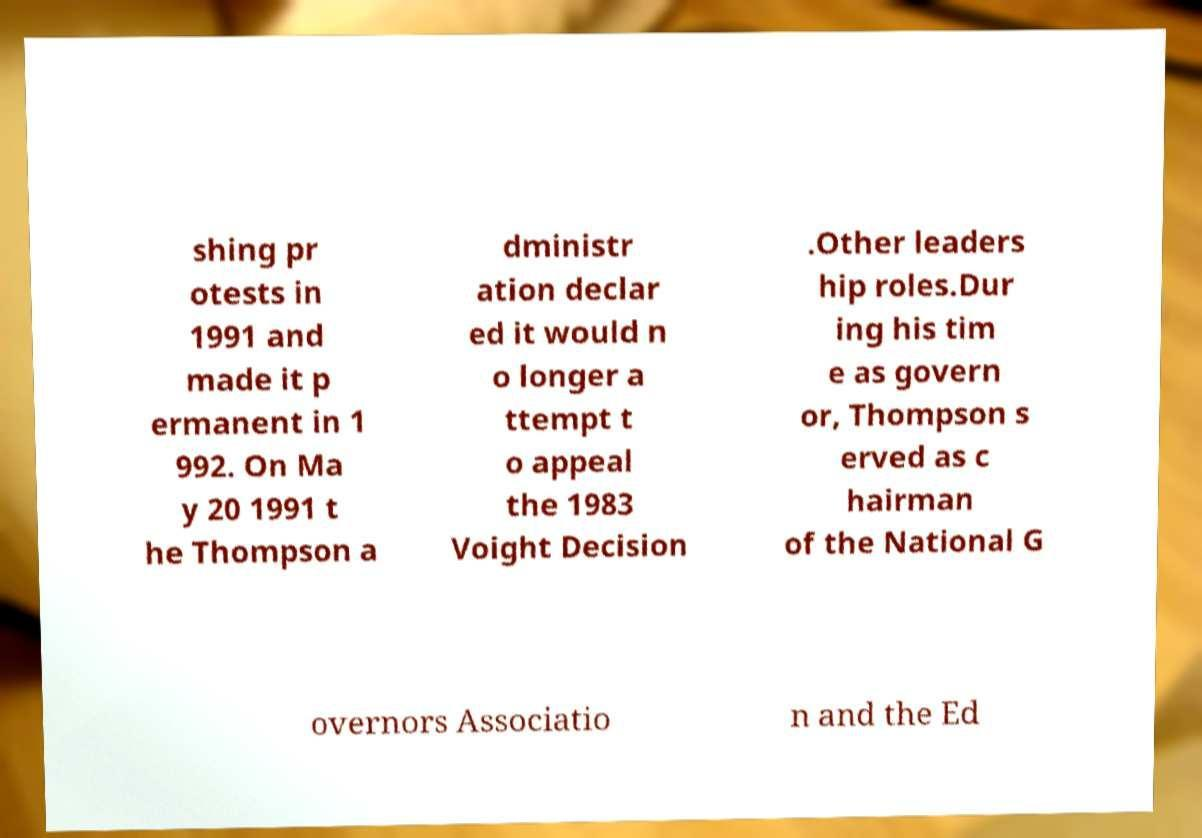Can you accurately transcribe the text from the provided image for me? shing pr otests in 1991 and made it p ermanent in 1 992. On Ma y 20 1991 t he Thompson a dministr ation declar ed it would n o longer a ttempt t o appeal the 1983 Voight Decision .Other leaders hip roles.Dur ing his tim e as govern or, Thompson s erved as c hairman of the National G overnors Associatio n and the Ed 